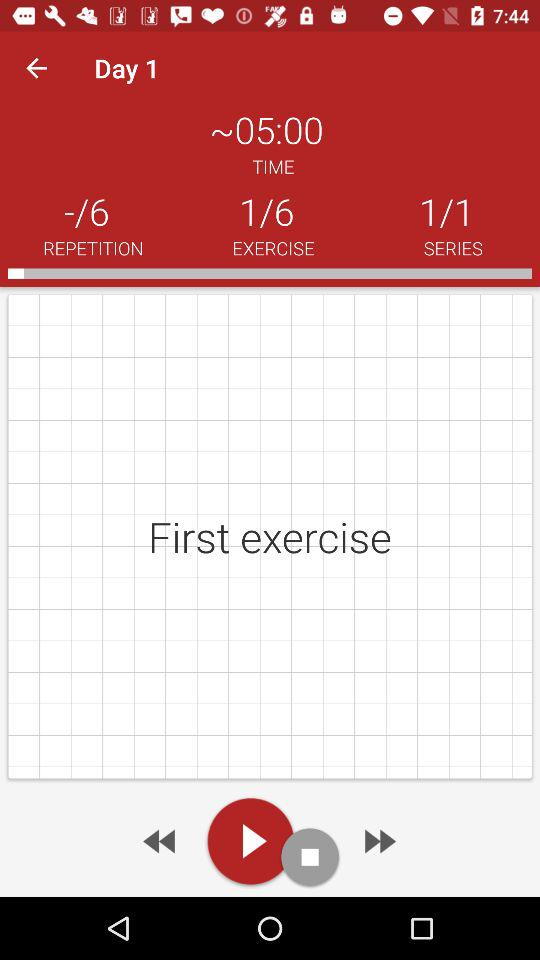At which exercise am I? You are at the first exercise. 